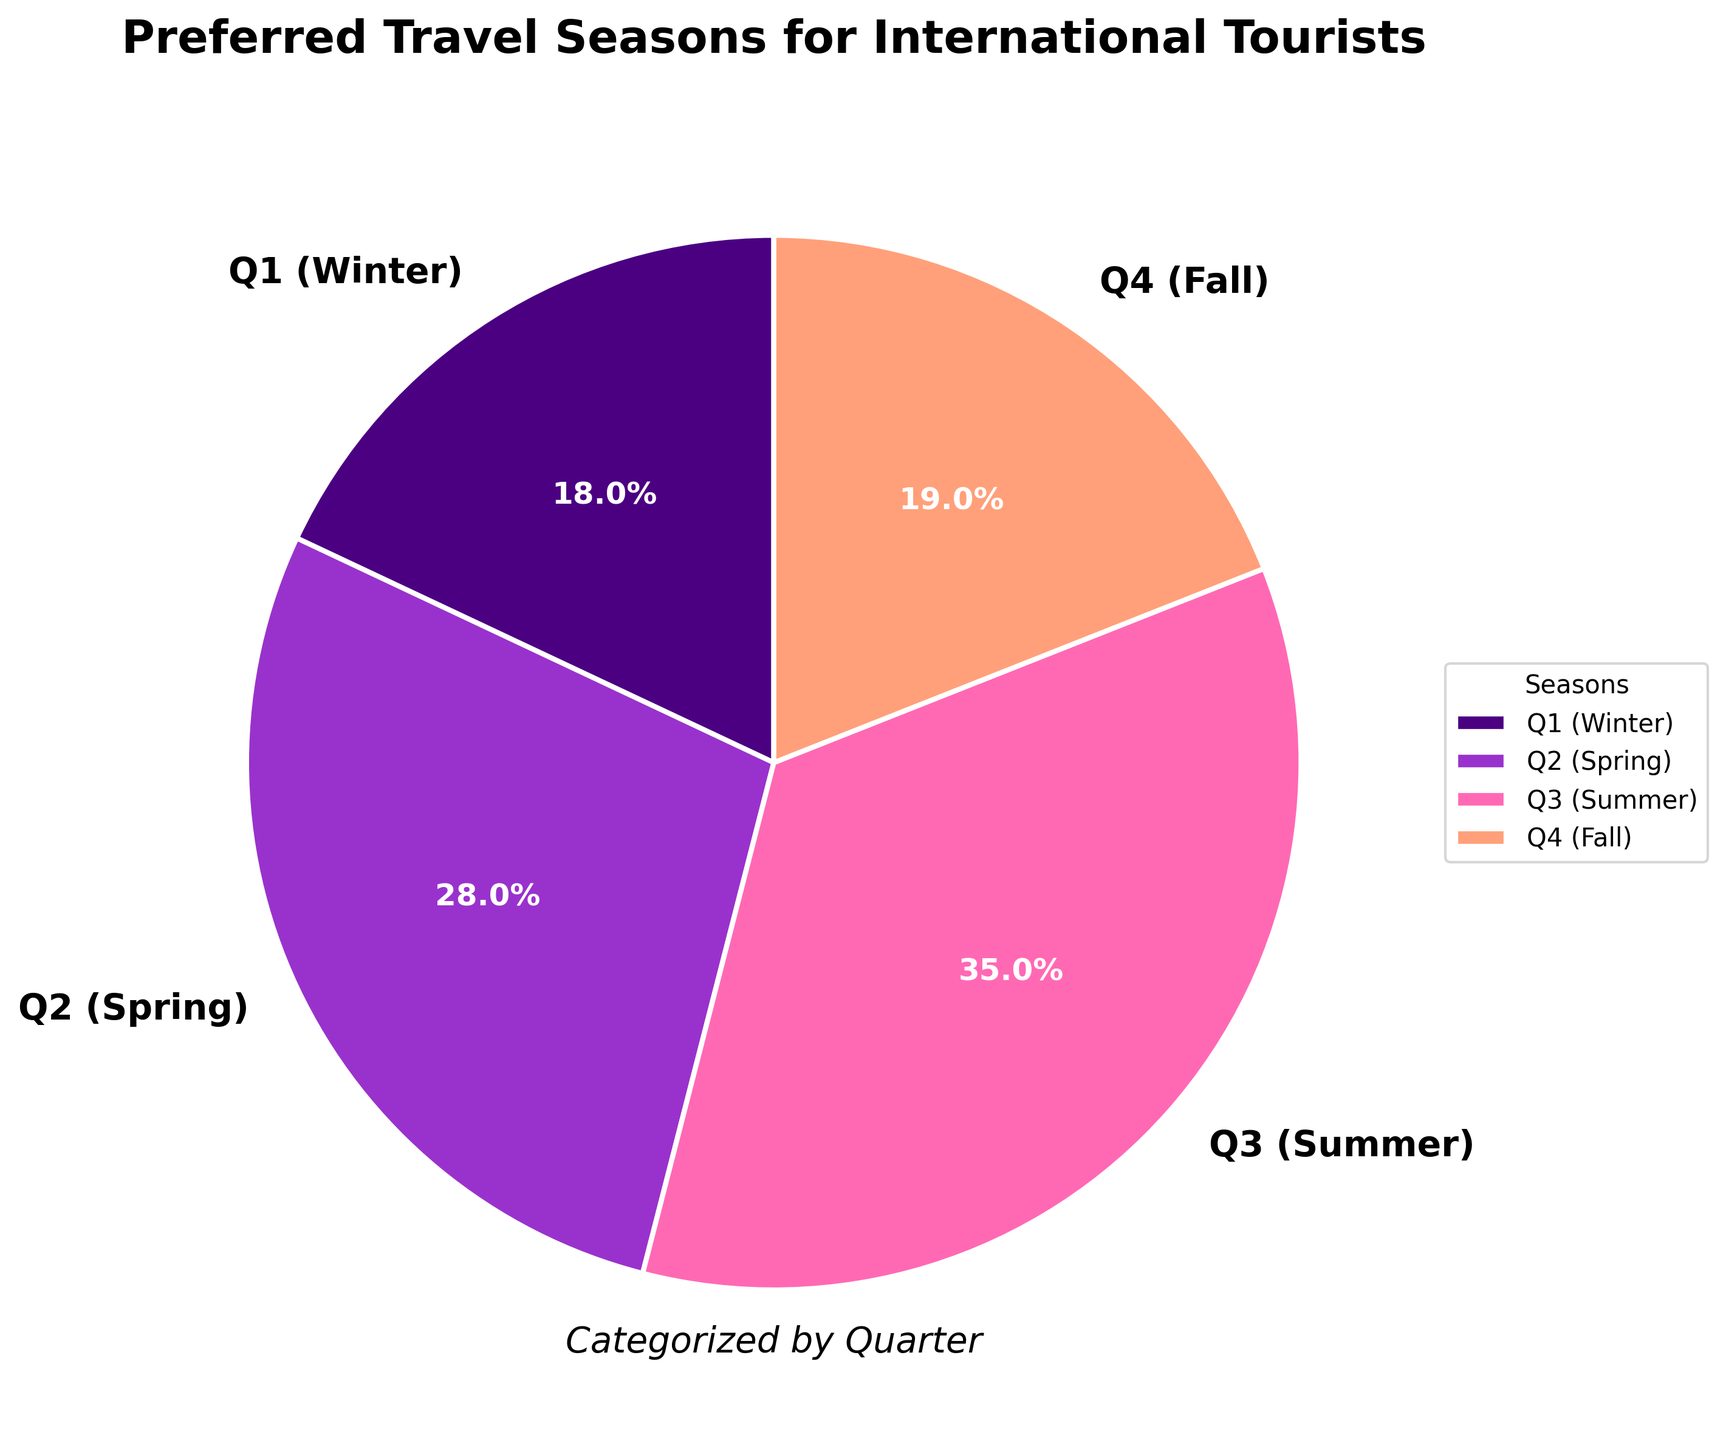What is the most preferred travel season for international tourists? The pie chart shows that the largest segment is Q3 (Summer), which covers 35% of the pie.
Answer: Q3 (Summer) What percentage of tourists prefer traveling in the spring? The pie chart has a segment labeled Q2 (Spring), which is represented with 28%.
Answer: 28% Between Q1 (Winter) and Q4 (Fall), which season is preferred more by international tourists? Comparing the two segments, Q1 (Winter) has 18% while Q4 (Fall) has 19%, making Q4 preferred slightly more.
Answer: Q4 (Fall) What is the combined percentage of tourists preferring Spring and Summer? By adding the percentages of Q2 (Spring) and Q3 (Summer), which are 28% and 35% respectively, we get 28% + 35% = 63%.
Answer: 63% Is Winter or Fall more popular among international tourists? Refer to the segments for Q1 (Winter) and Q4 (Fall). Q1 has 18% and Q4 has 19%, so Fall is slightly more popular.
Answer: Fall What percentage of tourists do not prefer traveling in Q3 (Summer)? The percentage of tourists who prefer Q3 (Summer) is 35%. Subtracting this from 100% gives 100% - 35% = 65%.
Answer: 65% What is the least preferred travel season for international tourists? The smallest segment in the pie chart is Q1 (Winter), which shows 18%.
Answer: Q1 (Winter) Which two consecutive quarters have the closest percentages of preferred travel seasons? Comparing adjacent quarters, the difference between Q4 (19%) and Q1 (18%) is the smallest at just 1%.
Answer: Q4 (Fall) and Q1 (Winter) Which segment has the highest color contrast in the pie chart? The brightest color visually contrasts most in the pie chart is the Q3 (Summer), given its pinkish hue compared to the darker and pastel colors of other segments.
Answer: Q3 (Summer) How much larger is the preference for Summer compared to Winter? Subtract the percentage of Q1 (Winter) from that of Q3 (Summer): 35% - 18% = 17%.
Answer: 17% 